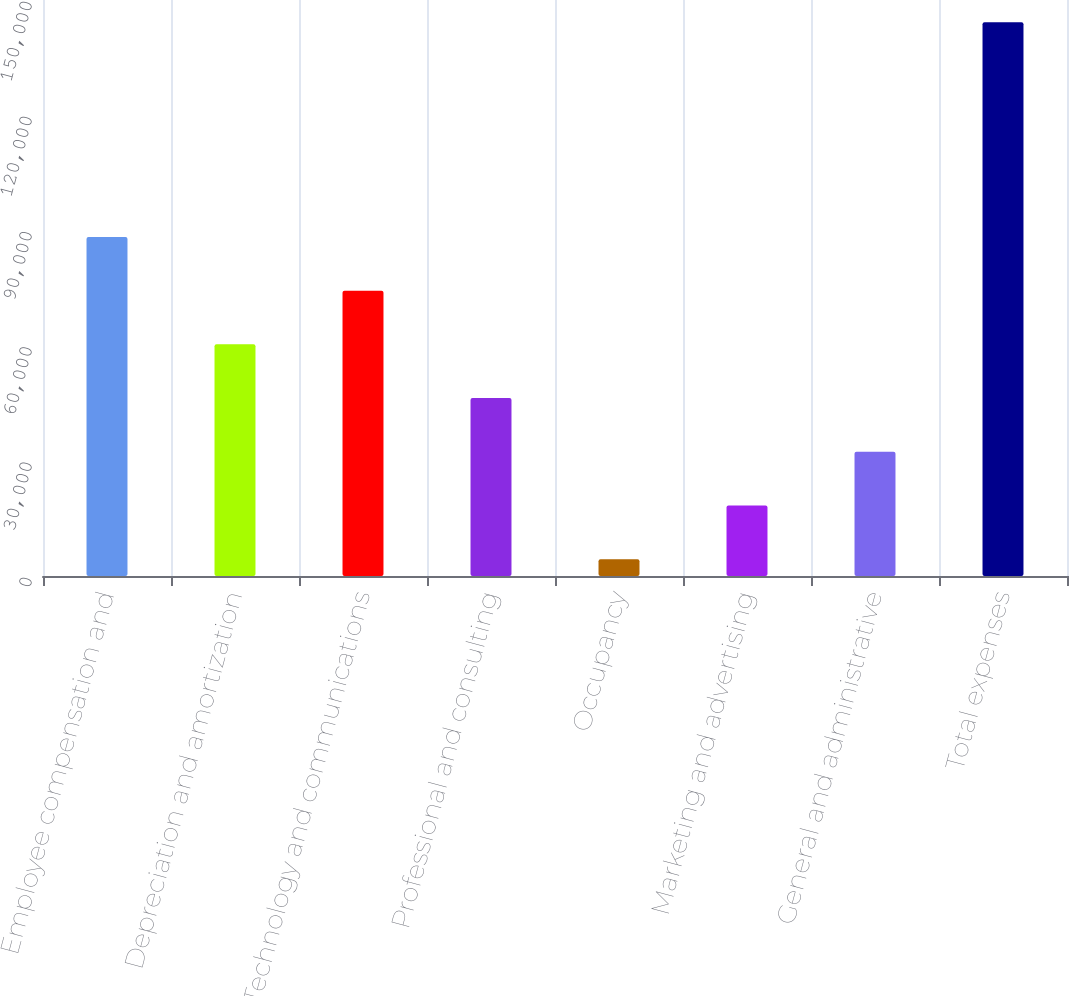Convert chart to OTSL. <chart><loc_0><loc_0><loc_500><loc_500><bar_chart><fcel>Employee compensation and<fcel>Depreciation and amortization<fcel>Technology and communications<fcel>Professional and consulting<fcel>Occupancy<fcel>Marketing and advertising<fcel>General and administrative<fcel>Total expenses<nl><fcel>88295.2<fcel>60323.8<fcel>74309.5<fcel>46338.1<fcel>4381<fcel>18366.7<fcel>32352.4<fcel>144238<nl></chart> 